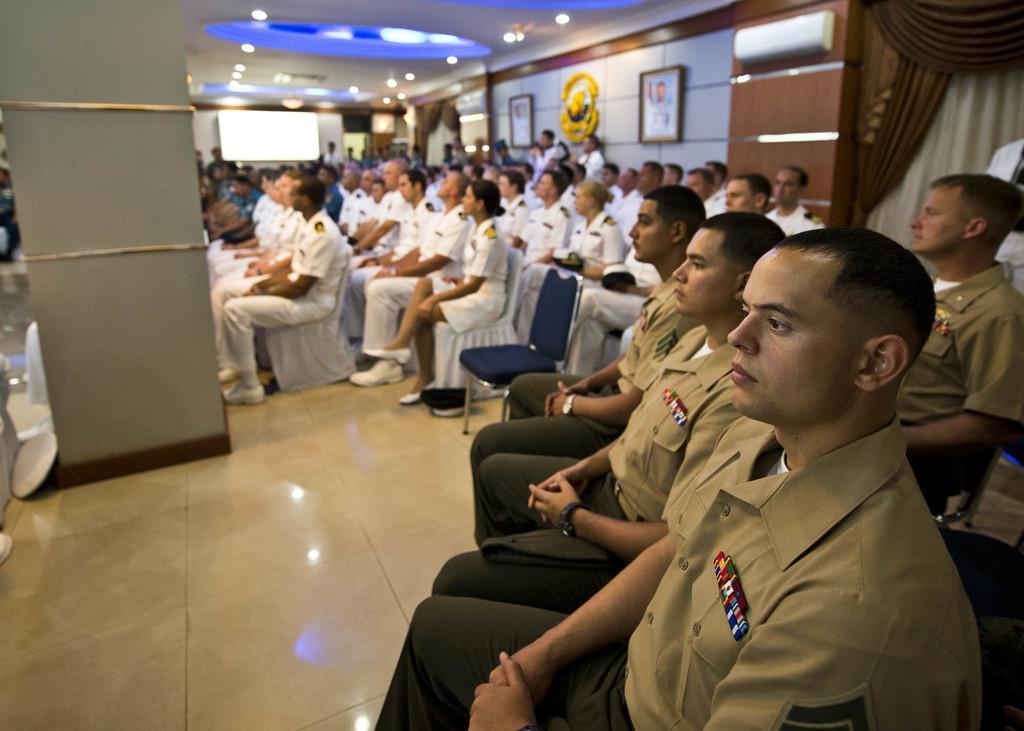Can you describe this image briefly? In the center of the image we can see a group of people are sitting on the chairs and they are in different color uniforms. In the background there is a wall, photo frames, curtains, lights, one board, one pillar, few people are standing and a few other objects. 